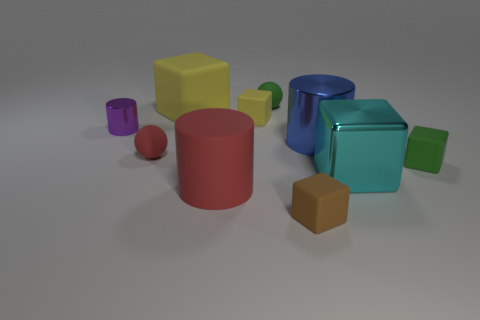Are the purple object and the big red cylinder made of the same material?
Provide a succinct answer. No. What size is the rubber thing that is both behind the small yellow matte thing and in front of the small green matte ball?
Your answer should be very brief. Large. There is a cyan metallic object that is the same size as the blue shiny cylinder; what is its shape?
Keep it short and to the point. Cube. What is the material of the yellow object in front of the yellow matte cube that is behind the tiny rubber cube that is to the left of the green matte sphere?
Offer a very short reply. Rubber. There is a brown object in front of the large blue shiny thing; is it the same shape as the large metallic thing that is left of the cyan object?
Your answer should be very brief. No. What number of other objects are the same material as the brown cube?
Make the answer very short. 6. Is the large cube right of the big blue shiny cylinder made of the same material as the tiny green object to the right of the tiny green matte ball?
Your response must be concise. No. There is a tiny green object that is the same material as the tiny green cube; what is its shape?
Provide a succinct answer. Sphere. Is there anything else that has the same color as the large metallic cylinder?
Keep it short and to the point. No. How many big cubes are there?
Your answer should be compact. 2. 